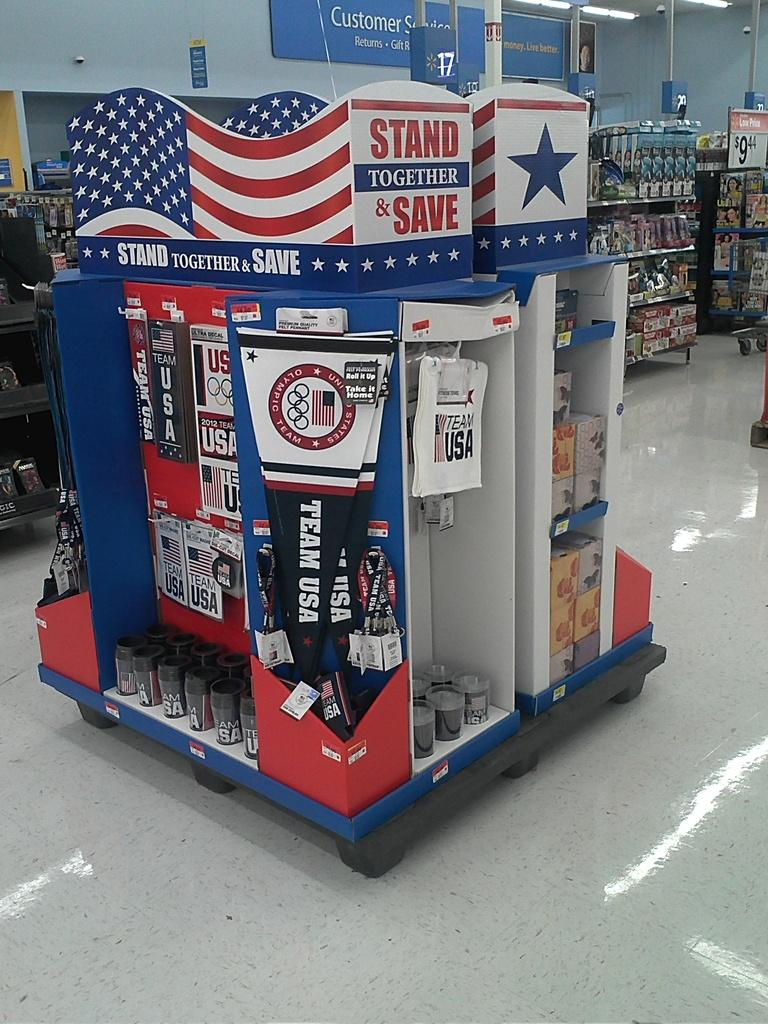Provide a one-sentence caption for the provided image. A sign that says to stand together and save is on top of a display in a store. 